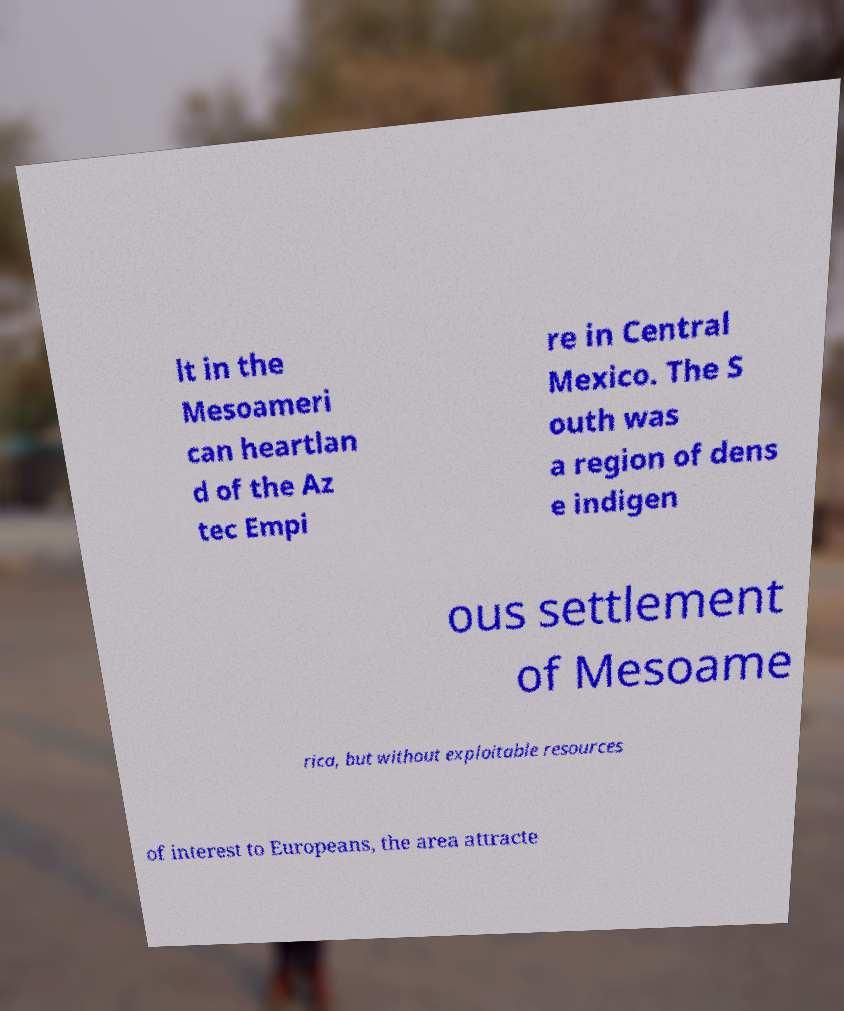Can you read and provide the text displayed in the image?This photo seems to have some interesting text. Can you extract and type it out for me? lt in the Mesoameri can heartlan d of the Az tec Empi re in Central Mexico. The S outh was a region of dens e indigen ous settlement of Mesoame rica, but without exploitable resources of interest to Europeans, the area attracte 